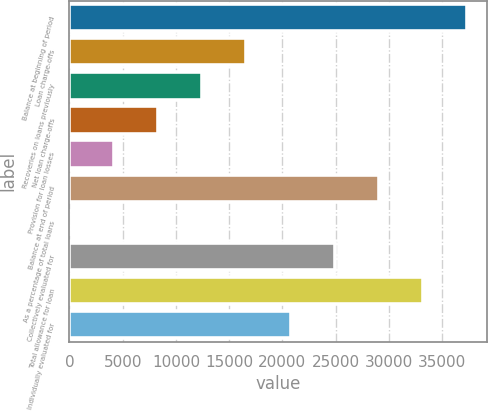Convert chart to OTSL. <chart><loc_0><loc_0><loc_500><loc_500><bar_chart><fcel>Balance at beginning of period<fcel>Loan charge-offs<fcel>Recoveries on loans previously<fcel>Net loan charge-offs<fcel>Provision for loan losses<fcel>Balance at end of period<fcel>As a percentage of total loans<fcel>Collectively evaluated for<fcel>Total allowance for loan<fcel>Individually evaluated for<nl><fcel>37382.5<fcel>16615.2<fcel>12461.7<fcel>8308.22<fcel>4154.75<fcel>29075.6<fcel>1.28<fcel>24922.1<fcel>33229<fcel>20768.6<nl></chart> 